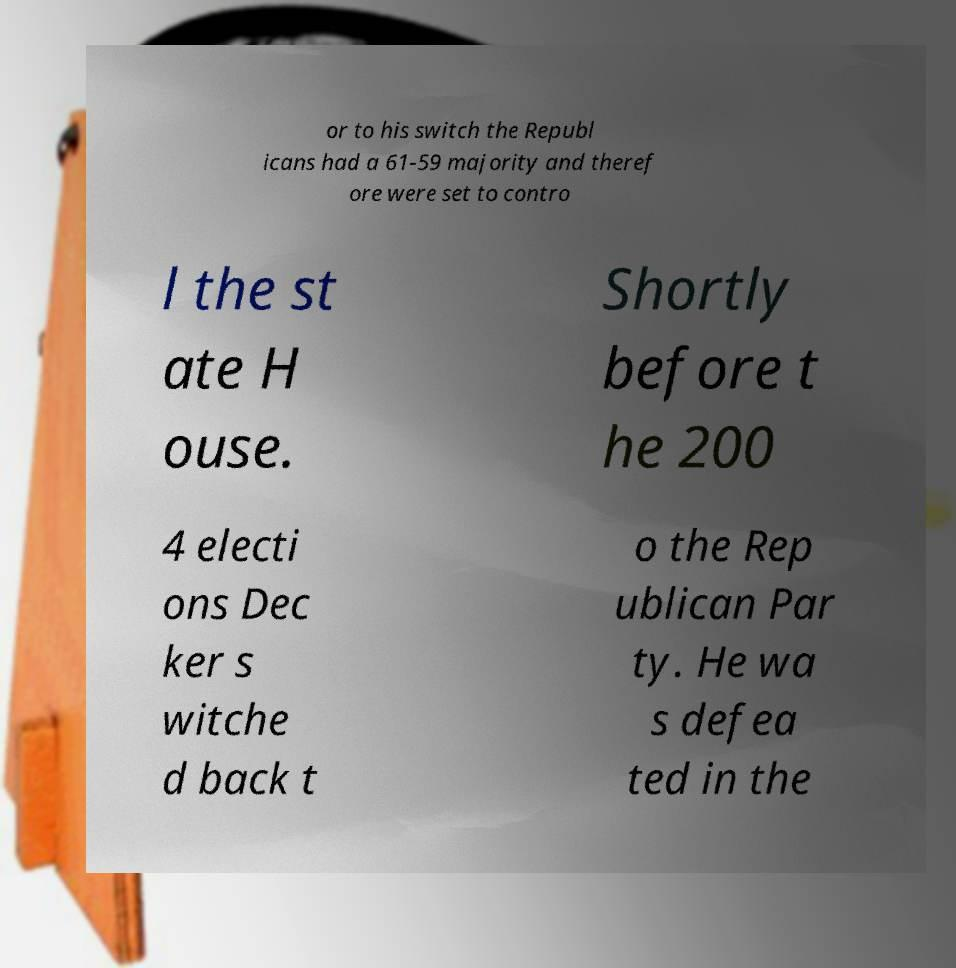Can you read and provide the text displayed in the image?This photo seems to have some interesting text. Can you extract and type it out for me? or to his switch the Republ icans had a 61-59 majority and theref ore were set to contro l the st ate H ouse. Shortly before t he 200 4 electi ons Dec ker s witche d back t o the Rep ublican Par ty. He wa s defea ted in the 